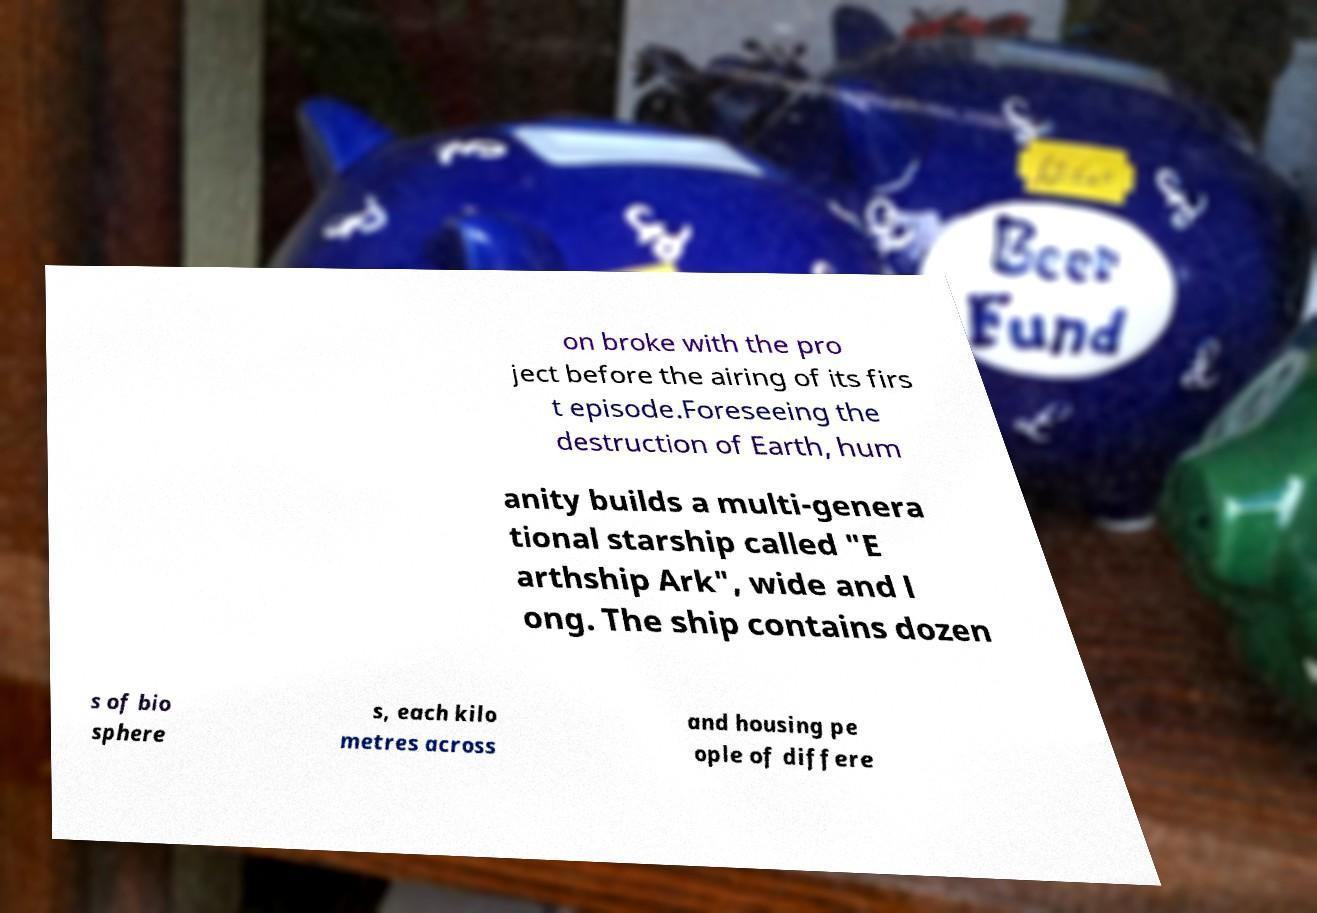For documentation purposes, I need the text within this image transcribed. Could you provide that? on broke with the pro ject before the airing of its firs t episode.Foreseeing the destruction of Earth, hum anity builds a multi-genera tional starship called "E arthship Ark", wide and l ong. The ship contains dozen s of bio sphere s, each kilo metres across and housing pe ople of differe 